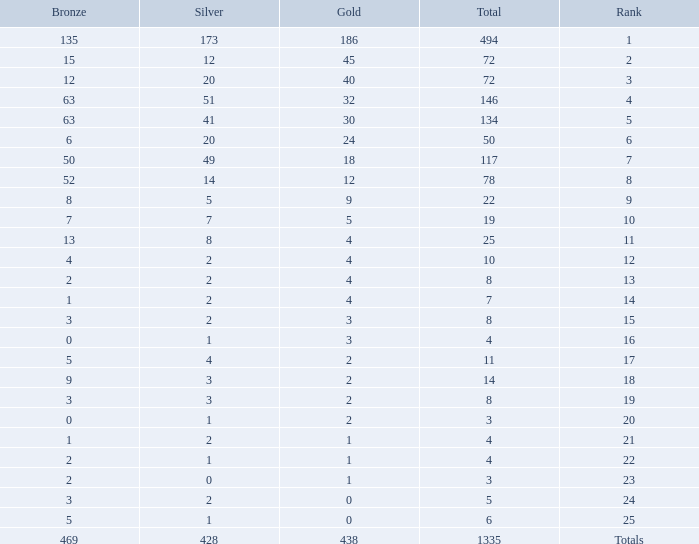What is the average number of gold medals when the total was 1335 medals, with more than 469 bronzes and more than 14 silvers? None. 